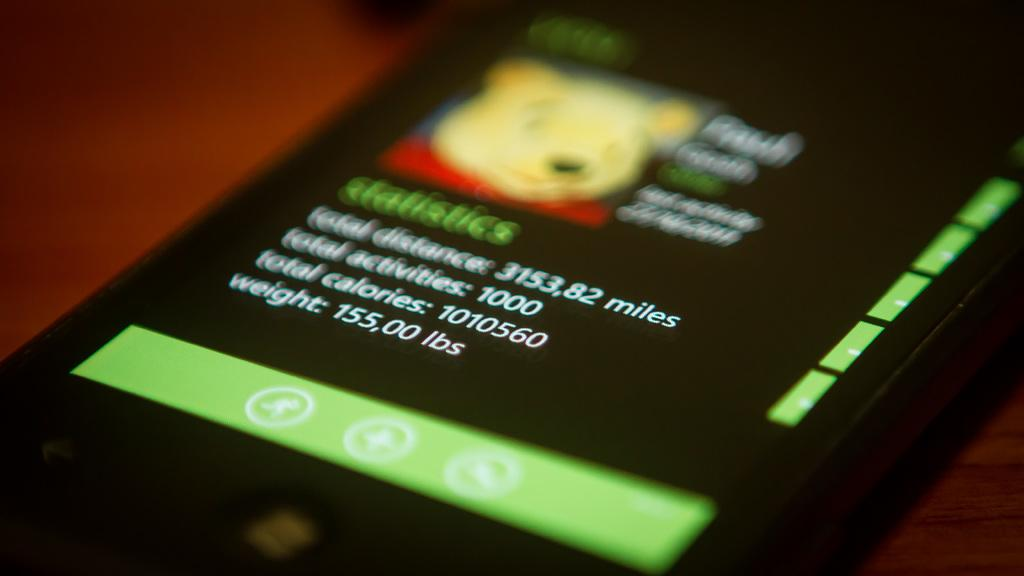<image>
Offer a succinct explanation of the picture presented. Winnie the Pooh is on a statistics app on a cell phone. 